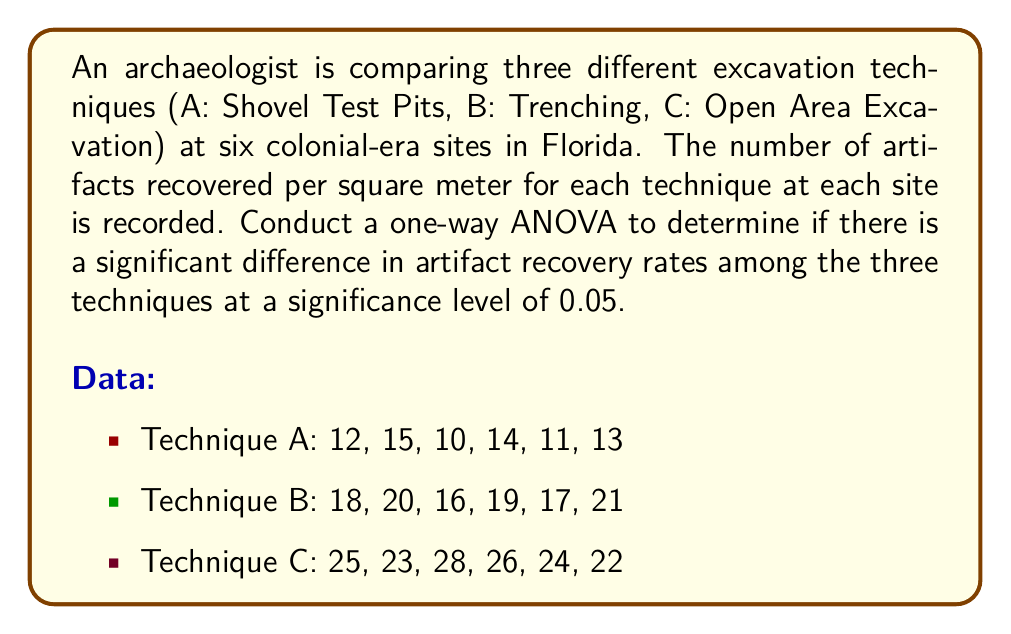What is the answer to this math problem? To conduct a one-way ANOVA, we'll follow these steps:

1. Calculate the sum of squares between groups (SSB), within groups (SSW), and total (SST).
2. Calculate the degrees of freedom for between groups (dfB), within groups (dfW), and total (dfT).
3. Calculate the mean squares between groups (MSB) and within groups (MSW).
4. Calculate the F-statistic.
5. Compare the F-statistic to the critical F-value.

Step 1: Calculate sum of squares

First, we need to calculate the grand mean:
$$ \bar{X} = \frac{12+15+10+14+11+13+18+20+16+19+17+21+25+23+28+26+24+22}{18} = 18.56 $$

Now, we can calculate SSB, SSW, and SST:

SSB:
$$ SSB = 6[(12.5-18.56)^2 + (18.5-18.56)^2 + (24.67-18.56)^2] = 540.11 $$

SSW:
$$ SSW = [(12-12.5)^2 + (15-12.5)^2 + ... + (22-24.67)^2] = 82.83 $$

SST:
$$ SST = SSB + SSW = 540.11 + 82.83 = 622.94 $$

Step 2: Calculate degrees of freedom

$$ df_B = 3 - 1 = 2 $$
$$ df_W = 18 - 3 = 15 $$
$$ df_T = 18 - 1 = 17 $$

Step 3: Calculate mean squares

$$ MSB = \frac{SSB}{df_B} = \frac{540.11}{2} = 270.06 $$
$$ MSW = \frac{SSW}{df_W} = \frac{82.83}{15} = 5.52 $$

Step 4: Calculate F-statistic

$$ F = \frac{MSB}{MSW} = \frac{270.06}{5.52} = 48.92 $$

Step 5: Compare F-statistic to critical F-value

The critical F-value for $\alpha = 0.05$, $df_B = 2$, and $df_W = 15$ is approximately 3.68.

Since our calculated F-statistic (48.92) is greater than the critical F-value (3.68), we reject the null hypothesis.
Answer: The one-way ANOVA results show a significant difference in artifact recovery rates among the three excavation techniques (F(2,15) = 48.92, p < 0.05). We reject the null hypothesis and conclude that at least one of the excavation techniques has a significantly different artifact recovery rate compared to the others. 